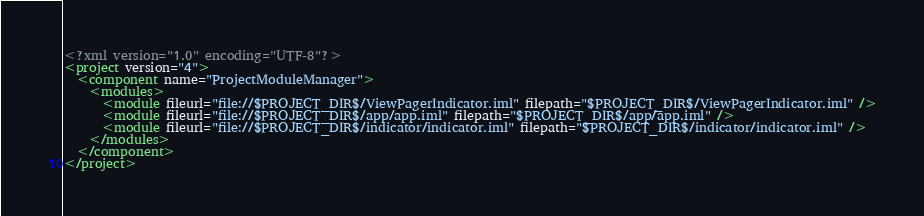Convert code to text. <code><loc_0><loc_0><loc_500><loc_500><_XML_><?xml version="1.0" encoding="UTF-8"?>
<project version="4">
  <component name="ProjectModuleManager">
    <modules>
      <module fileurl="file://$PROJECT_DIR$/ViewPagerIndicator.iml" filepath="$PROJECT_DIR$/ViewPagerIndicator.iml" />
      <module fileurl="file://$PROJECT_DIR$/app/app.iml" filepath="$PROJECT_DIR$/app/app.iml" />
      <module fileurl="file://$PROJECT_DIR$/indicator/indicator.iml" filepath="$PROJECT_DIR$/indicator/indicator.iml" />
    </modules>
  </component>
</project></code> 